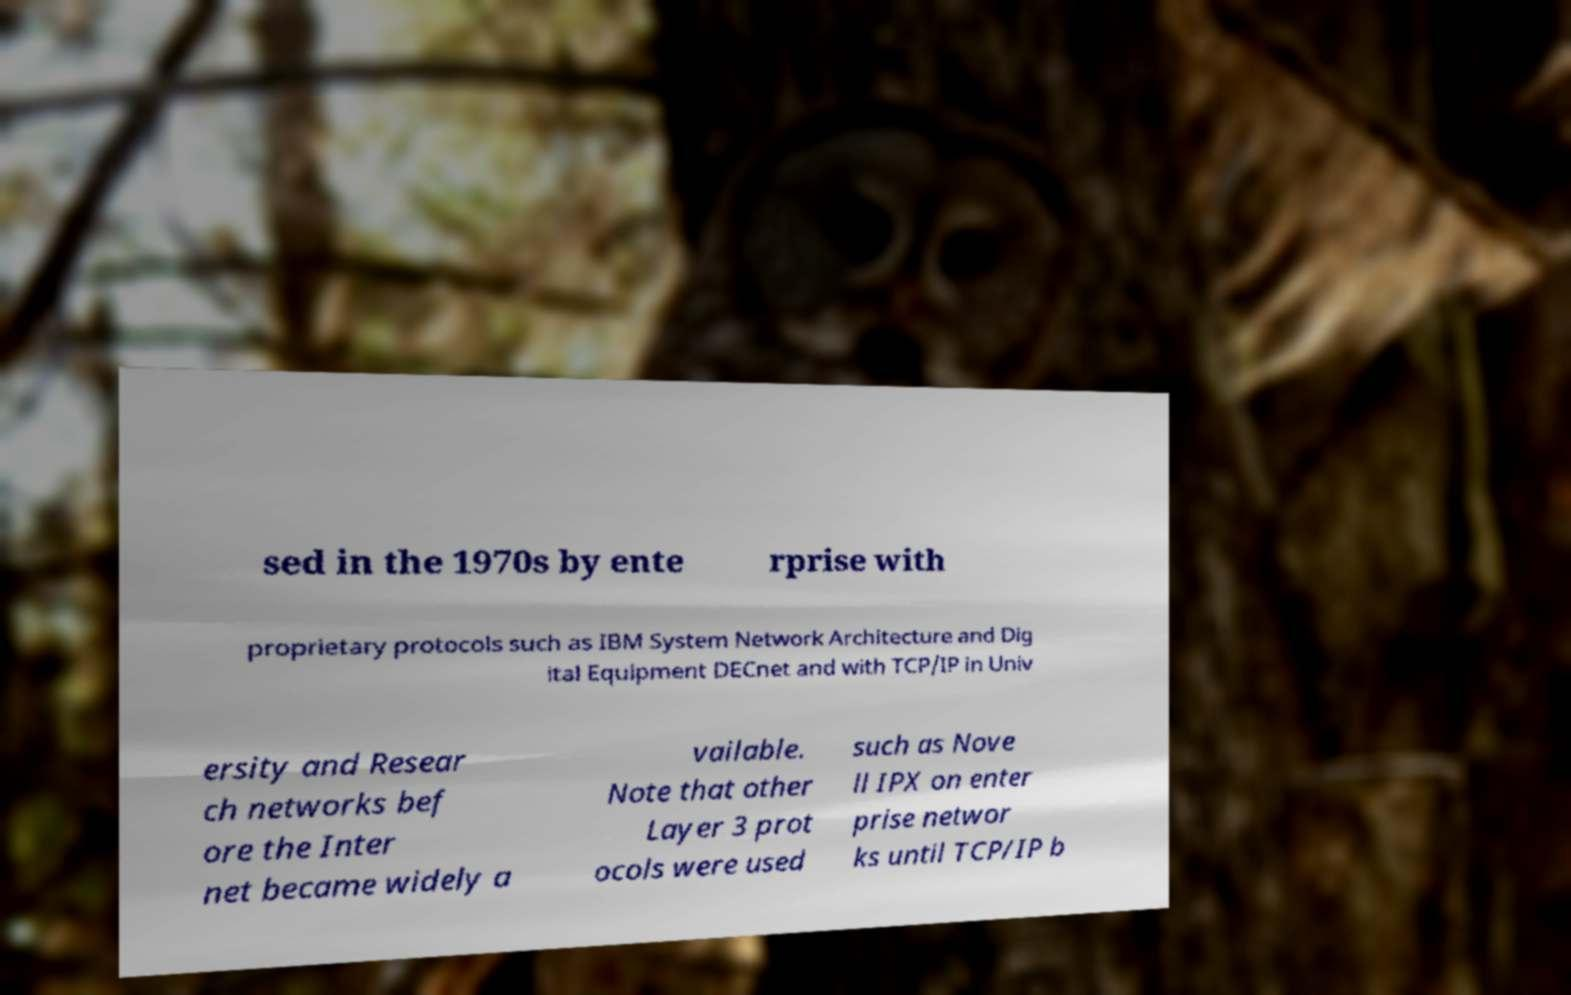Could you extract and type out the text from this image? sed in the 1970s by ente rprise with proprietary protocols such as IBM System Network Architecture and Dig ital Equipment DECnet and with TCP/IP in Univ ersity and Resear ch networks bef ore the Inter net became widely a vailable. Note that other Layer 3 prot ocols were used such as Nove ll IPX on enter prise networ ks until TCP/IP b 